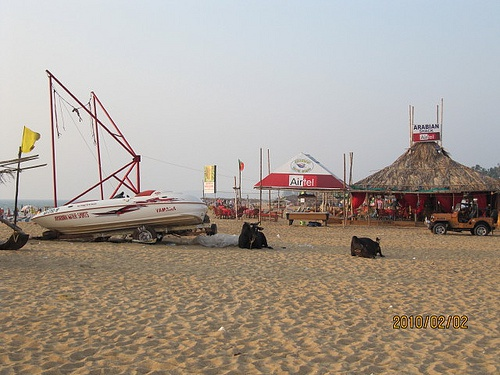Describe the objects in this image and their specific colors. I can see boat in lightgray, darkgray, and gray tones, truck in lightgray, black, maroon, and gray tones, cow in lightgray, black, and gray tones, cow in lightgray, black, gray, and maroon tones, and bench in lightgray, gray, brown, and maroon tones in this image. 